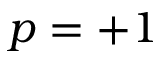Convert formula to latex. <formula><loc_0><loc_0><loc_500><loc_500>p = + 1</formula> 